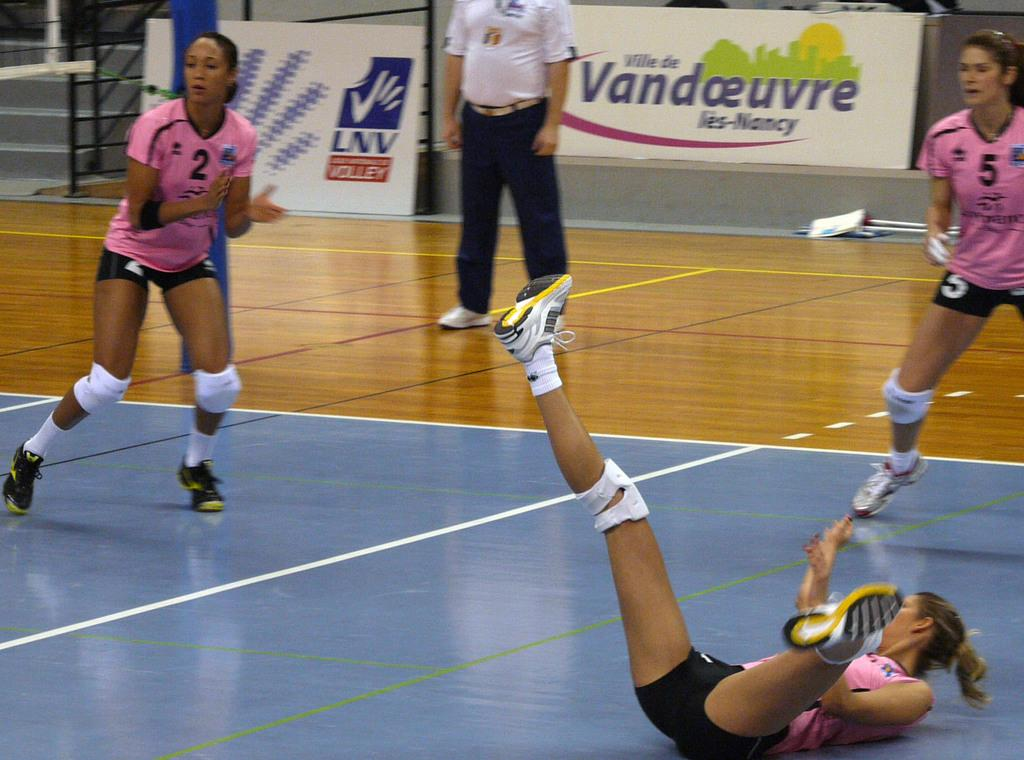How many people are present in the image? There are four persons in the image. What are some of the people doing in the image? Some people are playing a game on a surface. What can be seen in the background of the image? There are grills, banners, stairs, and other objects visible in the background of the image. What invention is being demonstrated by the people in the image? There is no invention being demonstrated in the image; the people are playing a game. What type of pet can be seen accompanying the people in the image? There is no pet present in the image; only the four people and the game they are playing are visible. 